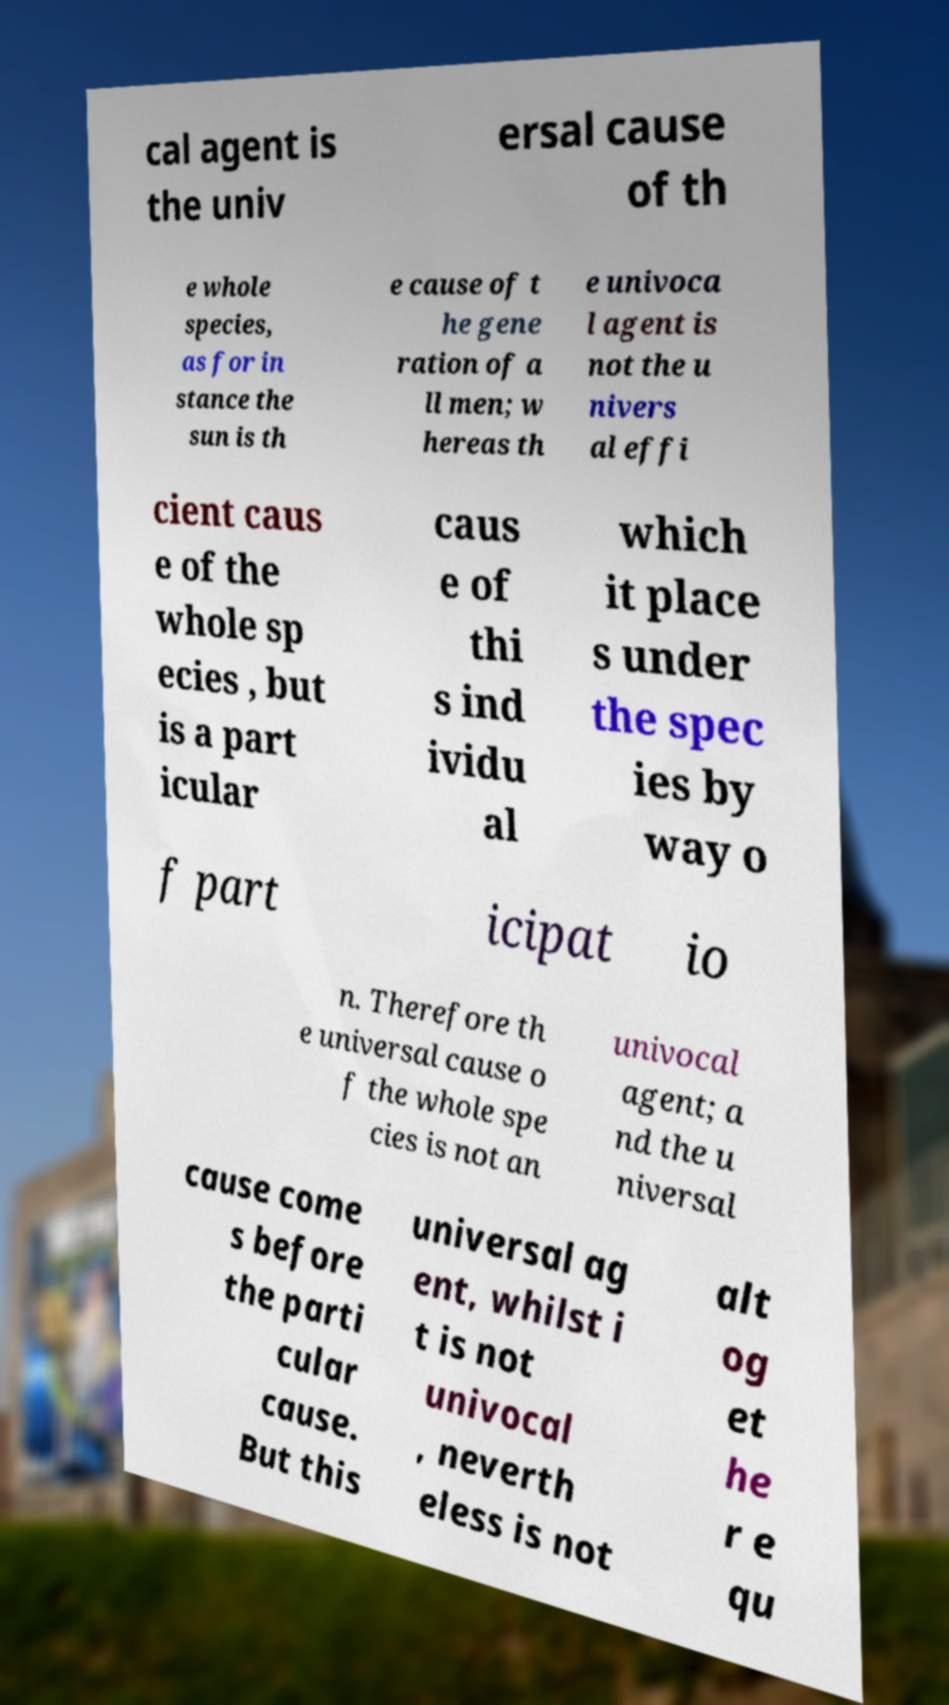Could you extract and type out the text from this image? cal agent is the univ ersal cause of th e whole species, as for in stance the sun is th e cause of t he gene ration of a ll men; w hereas th e univoca l agent is not the u nivers al effi cient caus e of the whole sp ecies , but is a part icular caus e of thi s ind ividu al which it place s under the spec ies by way o f part icipat io n. Therefore th e universal cause o f the whole spe cies is not an univocal agent; a nd the u niversal cause come s before the parti cular cause. But this universal ag ent, whilst i t is not univocal , neverth eless is not alt og et he r e qu 